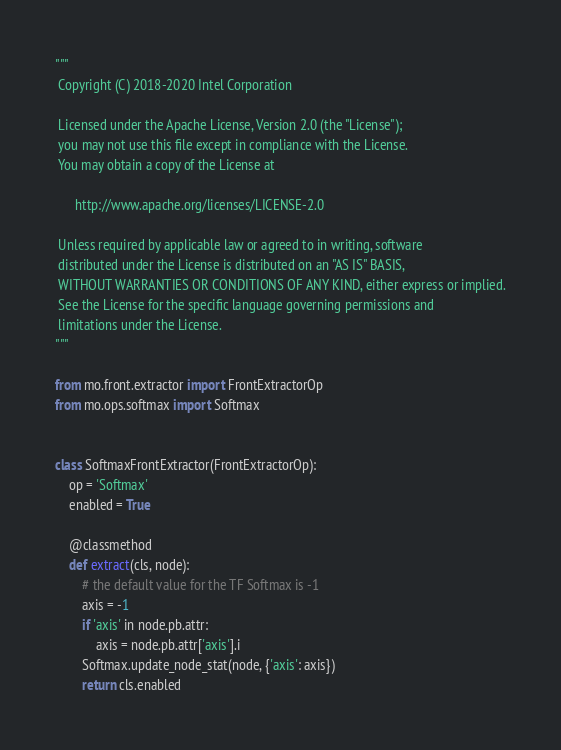<code> <loc_0><loc_0><loc_500><loc_500><_Python_>"""
 Copyright (C) 2018-2020 Intel Corporation

 Licensed under the Apache License, Version 2.0 (the "License");
 you may not use this file except in compliance with the License.
 You may obtain a copy of the License at

      http://www.apache.org/licenses/LICENSE-2.0

 Unless required by applicable law or agreed to in writing, software
 distributed under the License is distributed on an "AS IS" BASIS,
 WITHOUT WARRANTIES OR CONDITIONS OF ANY KIND, either express or implied.
 See the License for the specific language governing permissions and
 limitations under the License.
"""

from mo.front.extractor import FrontExtractorOp
from mo.ops.softmax import Softmax


class SoftmaxFrontExtractor(FrontExtractorOp):
    op = 'Softmax'
    enabled = True

    @classmethod
    def extract(cls, node):
        # the default value for the TF Softmax is -1
        axis = -1
        if 'axis' in node.pb.attr:
            axis = node.pb.attr['axis'].i
        Softmax.update_node_stat(node, {'axis': axis})
        return cls.enabled
</code> 